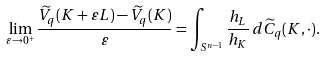<formula> <loc_0><loc_0><loc_500><loc_500>\lim _ { \varepsilon \to 0 ^ { + } } \frac { \widetilde { V } _ { q } ( K + \varepsilon L ) - \widetilde { V } _ { q } ( K ) } { \varepsilon } = \int _ { S ^ { n - 1 } } \frac { h _ { L } } { h _ { K } } \, d \widetilde { C } _ { q } ( K , \cdot ) .</formula> 